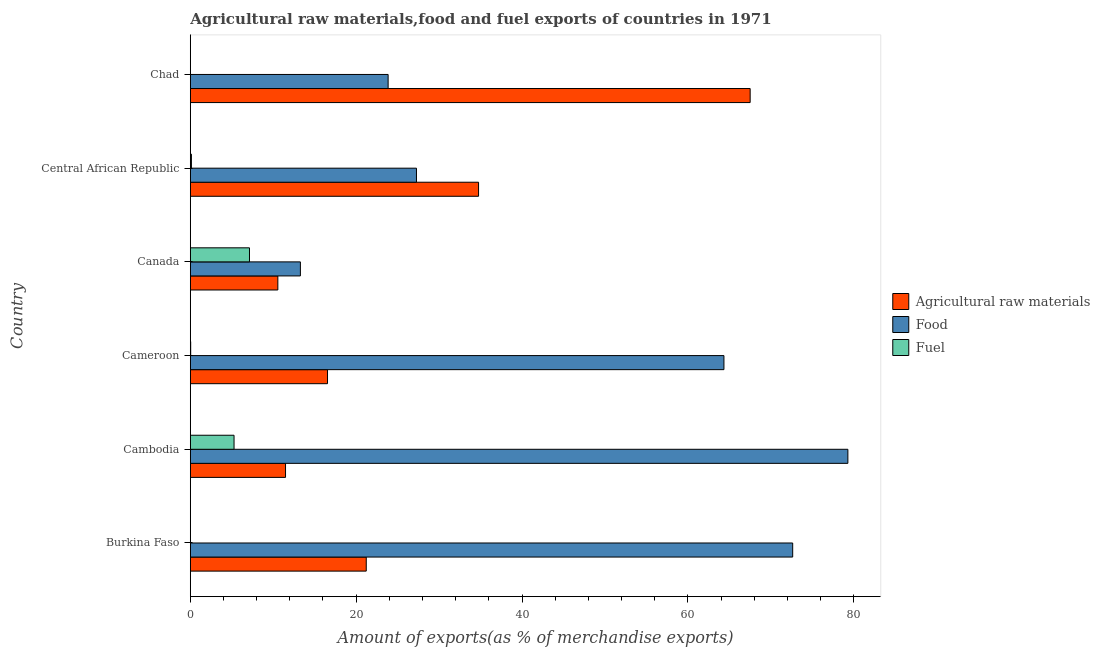How many bars are there on the 3rd tick from the top?
Offer a terse response. 3. How many bars are there on the 5th tick from the bottom?
Offer a very short reply. 3. What is the label of the 4th group of bars from the top?
Keep it short and to the point. Cameroon. What is the percentage of food exports in Chad?
Keep it short and to the point. 23.85. Across all countries, what is the maximum percentage of raw materials exports?
Your response must be concise. 67.51. Across all countries, what is the minimum percentage of fuel exports?
Your answer should be very brief. 0.01. In which country was the percentage of food exports maximum?
Give a very brief answer. Cambodia. In which country was the percentage of food exports minimum?
Keep it short and to the point. Canada. What is the total percentage of food exports in the graph?
Your answer should be very brief. 280.68. What is the difference between the percentage of fuel exports in Cameroon and that in Canada?
Ensure brevity in your answer.  -7.09. What is the difference between the percentage of fuel exports in Cambodia and the percentage of food exports in Burkina Faso?
Ensure brevity in your answer.  -67.36. What is the average percentage of food exports per country?
Make the answer very short. 46.78. What is the difference between the percentage of raw materials exports and percentage of food exports in Canada?
Your answer should be compact. -2.72. In how many countries, is the percentage of food exports greater than 72 %?
Provide a succinct answer. 2. What is the ratio of the percentage of food exports in Canada to that in Central African Republic?
Provide a short and direct response. 0.49. Is the difference between the percentage of raw materials exports in Burkina Faso and Cameroon greater than the difference between the percentage of food exports in Burkina Faso and Cameroon?
Offer a very short reply. No. What is the difference between the highest and the second highest percentage of raw materials exports?
Provide a succinct answer. 32.75. What is the difference between the highest and the lowest percentage of food exports?
Give a very brief answer. 66.02. In how many countries, is the percentage of fuel exports greater than the average percentage of fuel exports taken over all countries?
Provide a short and direct response. 2. What does the 2nd bar from the top in Central African Republic represents?
Provide a succinct answer. Food. What does the 1st bar from the bottom in Cameroon represents?
Offer a terse response. Agricultural raw materials. Is it the case that in every country, the sum of the percentage of raw materials exports and percentage of food exports is greater than the percentage of fuel exports?
Your answer should be compact. Yes. How many countries are there in the graph?
Your answer should be very brief. 6. Does the graph contain grids?
Keep it short and to the point. No. What is the title of the graph?
Make the answer very short. Agricultural raw materials,food and fuel exports of countries in 1971. What is the label or title of the X-axis?
Your answer should be very brief. Amount of exports(as % of merchandise exports). What is the Amount of exports(as % of merchandise exports) of Agricultural raw materials in Burkina Faso?
Keep it short and to the point. 21.22. What is the Amount of exports(as % of merchandise exports) of Food in Burkina Faso?
Provide a short and direct response. 72.64. What is the Amount of exports(as % of merchandise exports) of Fuel in Burkina Faso?
Your answer should be very brief. 0.02. What is the Amount of exports(as % of merchandise exports) in Agricultural raw materials in Cambodia?
Ensure brevity in your answer.  11.48. What is the Amount of exports(as % of merchandise exports) in Food in Cambodia?
Your answer should be compact. 79.29. What is the Amount of exports(as % of merchandise exports) in Fuel in Cambodia?
Offer a terse response. 5.28. What is the Amount of exports(as % of merchandise exports) in Agricultural raw materials in Cameroon?
Your answer should be very brief. 16.55. What is the Amount of exports(as % of merchandise exports) in Food in Cameroon?
Offer a terse response. 64.35. What is the Amount of exports(as % of merchandise exports) of Fuel in Cameroon?
Your response must be concise. 0.05. What is the Amount of exports(as % of merchandise exports) of Agricultural raw materials in Canada?
Give a very brief answer. 10.56. What is the Amount of exports(as % of merchandise exports) of Food in Canada?
Make the answer very short. 13.28. What is the Amount of exports(as % of merchandise exports) of Fuel in Canada?
Your answer should be very brief. 7.14. What is the Amount of exports(as % of merchandise exports) of Agricultural raw materials in Central African Republic?
Ensure brevity in your answer.  34.76. What is the Amount of exports(as % of merchandise exports) in Food in Central African Republic?
Your answer should be very brief. 27.27. What is the Amount of exports(as % of merchandise exports) of Fuel in Central African Republic?
Your answer should be compact. 0.14. What is the Amount of exports(as % of merchandise exports) of Agricultural raw materials in Chad?
Give a very brief answer. 67.51. What is the Amount of exports(as % of merchandise exports) in Food in Chad?
Provide a succinct answer. 23.85. What is the Amount of exports(as % of merchandise exports) in Fuel in Chad?
Offer a very short reply. 0.01. Across all countries, what is the maximum Amount of exports(as % of merchandise exports) in Agricultural raw materials?
Make the answer very short. 67.51. Across all countries, what is the maximum Amount of exports(as % of merchandise exports) of Food?
Offer a terse response. 79.29. Across all countries, what is the maximum Amount of exports(as % of merchandise exports) of Fuel?
Provide a short and direct response. 7.14. Across all countries, what is the minimum Amount of exports(as % of merchandise exports) of Agricultural raw materials?
Ensure brevity in your answer.  10.56. Across all countries, what is the minimum Amount of exports(as % of merchandise exports) of Food?
Your response must be concise. 13.28. Across all countries, what is the minimum Amount of exports(as % of merchandise exports) in Fuel?
Your response must be concise. 0.01. What is the total Amount of exports(as % of merchandise exports) in Agricultural raw materials in the graph?
Make the answer very short. 162.08. What is the total Amount of exports(as % of merchandise exports) of Food in the graph?
Make the answer very short. 280.68. What is the total Amount of exports(as % of merchandise exports) of Fuel in the graph?
Make the answer very short. 12.63. What is the difference between the Amount of exports(as % of merchandise exports) in Agricultural raw materials in Burkina Faso and that in Cambodia?
Your answer should be very brief. 9.73. What is the difference between the Amount of exports(as % of merchandise exports) of Food in Burkina Faso and that in Cambodia?
Your answer should be very brief. -6.65. What is the difference between the Amount of exports(as % of merchandise exports) of Fuel in Burkina Faso and that in Cambodia?
Your answer should be compact. -5.25. What is the difference between the Amount of exports(as % of merchandise exports) in Agricultural raw materials in Burkina Faso and that in Cameroon?
Your answer should be very brief. 4.67. What is the difference between the Amount of exports(as % of merchandise exports) in Food in Burkina Faso and that in Cameroon?
Give a very brief answer. 8.29. What is the difference between the Amount of exports(as % of merchandise exports) in Fuel in Burkina Faso and that in Cameroon?
Your answer should be compact. -0.02. What is the difference between the Amount of exports(as % of merchandise exports) of Agricultural raw materials in Burkina Faso and that in Canada?
Make the answer very short. 10.66. What is the difference between the Amount of exports(as % of merchandise exports) of Food in Burkina Faso and that in Canada?
Your answer should be compact. 59.36. What is the difference between the Amount of exports(as % of merchandise exports) of Fuel in Burkina Faso and that in Canada?
Your answer should be very brief. -7.11. What is the difference between the Amount of exports(as % of merchandise exports) of Agricultural raw materials in Burkina Faso and that in Central African Republic?
Your answer should be very brief. -13.54. What is the difference between the Amount of exports(as % of merchandise exports) in Food in Burkina Faso and that in Central African Republic?
Keep it short and to the point. 45.37. What is the difference between the Amount of exports(as % of merchandise exports) in Fuel in Burkina Faso and that in Central African Republic?
Your response must be concise. -0.11. What is the difference between the Amount of exports(as % of merchandise exports) of Agricultural raw materials in Burkina Faso and that in Chad?
Your answer should be very brief. -46.29. What is the difference between the Amount of exports(as % of merchandise exports) of Food in Burkina Faso and that in Chad?
Offer a very short reply. 48.78. What is the difference between the Amount of exports(as % of merchandise exports) of Fuel in Burkina Faso and that in Chad?
Provide a succinct answer. 0.01. What is the difference between the Amount of exports(as % of merchandise exports) in Agricultural raw materials in Cambodia and that in Cameroon?
Your answer should be compact. -5.06. What is the difference between the Amount of exports(as % of merchandise exports) of Food in Cambodia and that in Cameroon?
Make the answer very short. 14.95. What is the difference between the Amount of exports(as % of merchandise exports) in Fuel in Cambodia and that in Cameroon?
Your response must be concise. 5.23. What is the difference between the Amount of exports(as % of merchandise exports) in Agricultural raw materials in Cambodia and that in Canada?
Offer a terse response. 0.93. What is the difference between the Amount of exports(as % of merchandise exports) in Food in Cambodia and that in Canada?
Give a very brief answer. 66.02. What is the difference between the Amount of exports(as % of merchandise exports) in Fuel in Cambodia and that in Canada?
Offer a terse response. -1.86. What is the difference between the Amount of exports(as % of merchandise exports) in Agricultural raw materials in Cambodia and that in Central African Republic?
Provide a short and direct response. -23.28. What is the difference between the Amount of exports(as % of merchandise exports) of Food in Cambodia and that in Central African Republic?
Your answer should be very brief. 52.02. What is the difference between the Amount of exports(as % of merchandise exports) in Fuel in Cambodia and that in Central African Republic?
Offer a terse response. 5.14. What is the difference between the Amount of exports(as % of merchandise exports) of Agricultural raw materials in Cambodia and that in Chad?
Provide a short and direct response. -56.03. What is the difference between the Amount of exports(as % of merchandise exports) in Food in Cambodia and that in Chad?
Ensure brevity in your answer.  55.44. What is the difference between the Amount of exports(as % of merchandise exports) in Fuel in Cambodia and that in Chad?
Provide a short and direct response. 5.27. What is the difference between the Amount of exports(as % of merchandise exports) of Agricultural raw materials in Cameroon and that in Canada?
Give a very brief answer. 5.99. What is the difference between the Amount of exports(as % of merchandise exports) of Food in Cameroon and that in Canada?
Keep it short and to the point. 51.07. What is the difference between the Amount of exports(as % of merchandise exports) in Fuel in Cameroon and that in Canada?
Provide a succinct answer. -7.09. What is the difference between the Amount of exports(as % of merchandise exports) in Agricultural raw materials in Cameroon and that in Central African Republic?
Make the answer very short. -18.21. What is the difference between the Amount of exports(as % of merchandise exports) in Food in Cameroon and that in Central African Republic?
Your response must be concise. 37.07. What is the difference between the Amount of exports(as % of merchandise exports) in Fuel in Cameroon and that in Central African Republic?
Keep it short and to the point. -0.09. What is the difference between the Amount of exports(as % of merchandise exports) in Agricultural raw materials in Cameroon and that in Chad?
Ensure brevity in your answer.  -50.96. What is the difference between the Amount of exports(as % of merchandise exports) of Food in Cameroon and that in Chad?
Ensure brevity in your answer.  40.49. What is the difference between the Amount of exports(as % of merchandise exports) of Fuel in Cameroon and that in Chad?
Offer a terse response. 0.04. What is the difference between the Amount of exports(as % of merchandise exports) of Agricultural raw materials in Canada and that in Central African Republic?
Your response must be concise. -24.2. What is the difference between the Amount of exports(as % of merchandise exports) of Food in Canada and that in Central African Republic?
Ensure brevity in your answer.  -14. What is the difference between the Amount of exports(as % of merchandise exports) in Fuel in Canada and that in Central African Republic?
Your response must be concise. 7. What is the difference between the Amount of exports(as % of merchandise exports) of Agricultural raw materials in Canada and that in Chad?
Provide a short and direct response. -56.95. What is the difference between the Amount of exports(as % of merchandise exports) of Food in Canada and that in Chad?
Provide a short and direct response. -10.58. What is the difference between the Amount of exports(as % of merchandise exports) of Fuel in Canada and that in Chad?
Your answer should be compact. 7.13. What is the difference between the Amount of exports(as % of merchandise exports) of Agricultural raw materials in Central African Republic and that in Chad?
Give a very brief answer. -32.75. What is the difference between the Amount of exports(as % of merchandise exports) in Food in Central African Republic and that in Chad?
Provide a short and direct response. 3.42. What is the difference between the Amount of exports(as % of merchandise exports) in Fuel in Central African Republic and that in Chad?
Your answer should be very brief. 0.13. What is the difference between the Amount of exports(as % of merchandise exports) of Agricultural raw materials in Burkina Faso and the Amount of exports(as % of merchandise exports) of Food in Cambodia?
Your answer should be compact. -58.07. What is the difference between the Amount of exports(as % of merchandise exports) of Agricultural raw materials in Burkina Faso and the Amount of exports(as % of merchandise exports) of Fuel in Cambodia?
Your response must be concise. 15.94. What is the difference between the Amount of exports(as % of merchandise exports) of Food in Burkina Faso and the Amount of exports(as % of merchandise exports) of Fuel in Cambodia?
Make the answer very short. 67.36. What is the difference between the Amount of exports(as % of merchandise exports) of Agricultural raw materials in Burkina Faso and the Amount of exports(as % of merchandise exports) of Food in Cameroon?
Your answer should be compact. -43.13. What is the difference between the Amount of exports(as % of merchandise exports) in Agricultural raw materials in Burkina Faso and the Amount of exports(as % of merchandise exports) in Fuel in Cameroon?
Make the answer very short. 21.17. What is the difference between the Amount of exports(as % of merchandise exports) in Food in Burkina Faso and the Amount of exports(as % of merchandise exports) in Fuel in Cameroon?
Make the answer very short. 72.59. What is the difference between the Amount of exports(as % of merchandise exports) in Agricultural raw materials in Burkina Faso and the Amount of exports(as % of merchandise exports) in Food in Canada?
Your answer should be compact. 7.94. What is the difference between the Amount of exports(as % of merchandise exports) in Agricultural raw materials in Burkina Faso and the Amount of exports(as % of merchandise exports) in Fuel in Canada?
Your response must be concise. 14.08. What is the difference between the Amount of exports(as % of merchandise exports) of Food in Burkina Faso and the Amount of exports(as % of merchandise exports) of Fuel in Canada?
Provide a succinct answer. 65.5. What is the difference between the Amount of exports(as % of merchandise exports) of Agricultural raw materials in Burkina Faso and the Amount of exports(as % of merchandise exports) of Food in Central African Republic?
Your answer should be very brief. -6.05. What is the difference between the Amount of exports(as % of merchandise exports) in Agricultural raw materials in Burkina Faso and the Amount of exports(as % of merchandise exports) in Fuel in Central African Republic?
Your answer should be very brief. 21.08. What is the difference between the Amount of exports(as % of merchandise exports) of Food in Burkina Faso and the Amount of exports(as % of merchandise exports) of Fuel in Central African Republic?
Your response must be concise. 72.5. What is the difference between the Amount of exports(as % of merchandise exports) in Agricultural raw materials in Burkina Faso and the Amount of exports(as % of merchandise exports) in Food in Chad?
Keep it short and to the point. -2.64. What is the difference between the Amount of exports(as % of merchandise exports) in Agricultural raw materials in Burkina Faso and the Amount of exports(as % of merchandise exports) in Fuel in Chad?
Ensure brevity in your answer.  21.21. What is the difference between the Amount of exports(as % of merchandise exports) of Food in Burkina Faso and the Amount of exports(as % of merchandise exports) of Fuel in Chad?
Your answer should be compact. 72.63. What is the difference between the Amount of exports(as % of merchandise exports) of Agricultural raw materials in Cambodia and the Amount of exports(as % of merchandise exports) of Food in Cameroon?
Your response must be concise. -52.86. What is the difference between the Amount of exports(as % of merchandise exports) of Agricultural raw materials in Cambodia and the Amount of exports(as % of merchandise exports) of Fuel in Cameroon?
Provide a short and direct response. 11.44. What is the difference between the Amount of exports(as % of merchandise exports) of Food in Cambodia and the Amount of exports(as % of merchandise exports) of Fuel in Cameroon?
Offer a very short reply. 79.25. What is the difference between the Amount of exports(as % of merchandise exports) in Agricultural raw materials in Cambodia and the Amount of exports(as % of merchandise exports) in Food in Canada?
Offer a terse response. -1.79. What is the difference between the Amount of exports(as % of merchandise exports) in Agricultural raw materials in Cambodia and the Amount of exports(as % of merchandise exports) in Fuel in Canada?
Give a very brief answer. 4.35. What is the difference between the Amount of exports(as % of merchandise exports) of Food in Cambodia and the Amount of exports(as % of merchandise exports) of Fuel in Canada?
Keep it short and to the point. 72.15. What is the difference between the Amount of exports(as % of merchandise exports) in Agricultural raw materials in Cambodia and the Amount of exports(as % of merchandise exports) in Food in Central African Republic?
Your response must be concise. -15.79. What is the difference between the Amount of exports(as % of merchandise exports) in Agricultural raw materials in Cambodia and the Amount of exports(as % of merchandise exports) in Fuel in Central African Republic?
Offer a very short reply. 11.35. What is the difference between the Amount of exports(as % of merchandise exports) of Food in Cambodia and the Amount of exports(as % of merchandise exports) of Fuel in Central African Republic?
Keep it short and to the point. 79.16. What is the difference between the Amount of exports(as % of merchandise exports) in Agricultural raw materials in Cambodia and the Amount of exports(as % of merchandise exports) in Food in Chad?
Your answer should be very brief. -12.37. What is the difference between the Amount of exports(as % of merchandise exports) in Agricultural raw materials in Cambodia and the Amount of exports(as % of merchandise exports) in Fuel in Chad?
Your answer should be compact. 11.47. What is the difference between the Amount of exports(as % of merchandise exports) of Food in Cambodia and the Amount of exports(as % of merchandise exports) of Fuel in Chad?
Provide a succinct answer. 79.28. What is the difference between the Amount of exports(as % of merchandise exports) of Agricultural raw materials in Cameroon and the Amount of exports(as % of merchandise exports) of Food in Canada?
Keep it short and to the point. 3.27. What is the difference between the Amount of exports(as % of merchandise exports) in Agricultural raw materials in Cameroon and the Amount of exports(as % of merchandise exports) in Fuel in Canada?
Provide a short and direct response. 9.41. What is the difference between the Amount of exports(as % of merchandise exports) in Food in Cameroon and the Amount of exports(as % of merchandise exports) in Fuel in Canada?
Offer a very short reply. 57.21. What is the difference between the Amount of exports(as % of merchandise exports) of Agricultural raw materials in Cameroon and the Amount of exports(as % of merchandise exports) of Food in Central African Republic?
Provide a succinct answer. -10.73. What is the difference between the Amount of exports(as % of merchandise exports) of Agricultural raw materials in Cameroon and the Amount of exports(as % of merchandise exports) of Fuel in Central African Republic?
Your response must be concise. 16.41. What is the difference between the Amount of exports(as % of merchandise exports) in Food in Cameroon and the Amount of exports(as % of merchandise exports) in Fuel in Central African Republic?
Offer a very short reply. 64.21. What is the difference between the Amount of exports(as % of merchandise exports) of Agricultural raw materials in Cameroon and the Amount of exports(as % of merchandise exports) of Food in Chad?
Your answer should be very brief. -7.31. What is the difference between the Amount of exports(as % of merchandise exports) of Agricultural raw materials in Cameroon and the Amount of exports(as % of merchandise exports) of Fuel in Chad?
Give a very brief answer. 16.54. What is the difference between the Amount of exports(as % of merchandise exports) in Food in Cameroon and the Amount of exports(as % of merchandise exports) in Fuel in Chad?
Your answer should be very brief. 64.34. What is the difference between the Amount of exports(as % of merchandise exports) of Agricultural raw materials in Canada and the Amount of exports(as % of merchandise exports) of Food in Central African Republic?
Ensure brevity in your answer.  -16.72. What is the difference between the Amount of exports(as % of merchandise exports) in Agricultural raw materials in Canada and the Amount of exports(as % of merchandise exports) in Fuel in Central African Republic?
Keep it short and to the point. 10.42. What is the difference between the Amount of exports(as % of merchandise exports) of Food in Canada and the Amount of exports(as % of merchandise exports) of Fuel in Central African Republic?
Keep it short and to the point. 13.14. What is the difference between the Amount of exports(as % of merchandise exports) of Agricultural raw materials in Canada and the Amount of exports(as % of merchandise exports) of Food in Chad?
Keep it short and to the point. -13.3. What is the difference between the Amount of exports(as % of merchandise exports) of Agricultural raw materials in Canada and the Amount of exports(as % of merchandise exports) of Fuel in Chad?
Your response must be concise. 10.55. What is the difference between the Amount of exports(as % of merchandise exports) of Food in Canada and the Amount of exports(as % of merchandise exports) of Fuel in Chad?
Provide a succinct answer. 13.27. What is the difference between the Amount of exports(as % of merchandise exports) of Agricultural raw materials in Central African Republic and the Amount of exports(as % of merchandise exports) of Food in Chad?
Ensure brevity in your answer.  10.91. What is the difference between the Amount of exports(as % of merchandise exports) in Agricultural raw materials in Central African Republic and the Amount of exports(as % of merchandise exports) in Fuel in Chad?
Keep it short and to the point. 34.75. What is the difference between the Amount of exports(as % of merchandise exports) of Food in Central African Republic and the Amount of exports(as % of merchandise exports) of Fuel in Chad?
Offer a terse response. 27.26. What is the average Amount of exports(as % of merchandise exports) of Agricultural raw materials per country?
Offer a terse response. 27.01. What is the average Amount of exports(as % of merchandise exports) in Food per country?
Provide a short and direct response. 46.78. What is the average Amount of exports(as % of merchandise exports) of Fuel per country?
Provide a short and direct response. 2.1. What is the difference between the Amount of exports(as % of merchandise exports) in Agricultural raw materials and Amount of exports(as % of merchandise exports) in Food in Burkina Faso?
Give a very brief answer. -51.42. What is the difference between the Amount of exports(as % of merchandise exports) in Agricultural raw materials and Amount of exports(as % of merchandise exports) in Fuel in Burkina Faso?
Your answer should be compact. 21.19. What is the difference between the Amount of exports(as % of merchandise exports) in Food and Amount of exports(as % of merchandise exports) in Fuel in Burkina Faso?
Keep it short and to the point. 72.61. What is the difference between the Amount of exports(as % of merchandise exports) in Agricultural raw materials and Amount of exports(as % of merchandise exports) in Food in Cambodia?
Offer a terse response. -67.81. What is the difference between the Amount of exports(as % of merchandise exports) in Agricultural raw materials and Amount of exports(as % of merchandise exports) in Fuel in Cambodia?
Provide a short and direct response. 6.21. What is the difference between the Amount of exports(as % of merchandise exports) in Food and Amount of exports(as % of merchandise exports) in Fuel in Cambodia?
Give a very brief answer. 74.02. What is the difference between the Amount of exports(as % of merchandise exports) of Agricultural raw materials and Amount of exports(as % of merchandise exports) of Food in Cameroon?
Make the answer very short. -47.8. What is the difference between the Amount of exports(as % of merchandise exports) in Agricultural raw materials and Amount of exports(as % of merchandise exports) in Fuel in Cameroon?
Provide a succinct answer. 16.5. What is the difference between the Amount of exports(as % of merchandise exports) of Food and Amount of exports(as % of merchandise exports) of Fuel in Cameroon?
Provide a succinct answer. 64.3. What is the difference between the Amount of exports(as % of merchandise exports) of Agricultural raw materials and Amount of exports(as % of merchandise exports) of Food in Canada?
Offer a very short reply. -2.72. What is the difference between the Amount of exports(as % of merchandise exports) of Agricultural raw materials and Amount of exports(as % of merchandise exports) of Fuel in Canada?
Your response must be concise. 3.42. What is the difference between the Amount of exports(as % of merchandise exports) in Food and Amount of exports(as % of merchandise exports) in Fuel in Canada?
Offer a terse response. 6.14. What is the difference between the Amount of exports(as % of merchandise exports) of Agricultural raw materials and Amount of exports(as % of merchandise exports) of Food in Central African Republic?
Ensure brevity in your answer.  7.49. What is the difference between the Amount of exports(as % of merchandise exports) in Agricultural raw materials and Amount of exports(as % of merchandise exports) in Fuel in Central African Republic?
Your answer should be very brief. 34.63. What is the difference between the Amount of exports(as % of merchandise exports) of Food and Amount of exports(as % of merchandise exports) of Fuel in Central African Republic?
Offer a very short reply. 27.14. What is the difference between the Amount of exports(as % of merchandise exports) in Agricultural raw materials and Amount of exports(as % of merchandise exports) in Food in Chad?
Ensure brevity in your answer.  43.66. What is the difference between the Amount of exports(as % of merchandise exports) of Agricultural raw materials and Amount of exports(as % of merchandise exports) of Fuel in Chad?
Make the answer very short. 67.5. What is the difference between the Amount of exports(as % of merchandise exports) of Food and Amount of exports(as % of merchandise exports) of Fuel in Chad?
Provide a succinct answer. 23.84. What is the ratio of the Amount of exports(as % of merchandise exports) of Agricultural raw materials in Burkina Faso to that in Cambodia?
Keep it short and to the point. 1.85. What is the ratio of the Amount of exports(as % of merchandise exports) in Food in Burkina Faso to that in Cambodia?
Your response must be concise. 0.92. What is the ratio of the Amount of exports(as % of merchandise exports) in Fuel in Burkina Faso to that in Cambodia?
Offer a very short reply. 0. What is the ratio of the Amount of exports(as % of merchandise exports) in Agricultural raw materials in Burkina Faso to that in Cameroon?
Keep it short and to the point. 1.28. What is the ratio of the Amount of exports(as % of merchandise exports) of Food in Burkina Faso to that in Cameroon?
Offer a very short reply. 1.13. What is the ratio of the Amount of exports(as % of merchandise exports) of Fuel in Burkina Faso to that in Cameroon?
Your answer should be very brief. 0.49. What is the ratio of the Amount of exports(as % of merchandise exports) in Agricultural raw materials in Burkina Faso to that in Canada?
Offer a very short reply. 2.01. What is the ratio of the Amount of exports(as % of merchandise exports) of Food in Burkina Faso to that in Canada?
Offer a very short reply. 5.47. What is the ratio of the Amount of exports(as % of merchandise exports) of Fuel in Burkina Faso to that in Canada?
Ensure brevity in your answer.  0. What is the ratio of the Amount of exports(as % of merchandise exports) in Agricultural raw materials in Burkina Faso to that in Central African Republic?
Give a very brief answer. 0.61. What is the ratio of the Amount of exports(as % of merchandise exports) of Food in Burkina Faso to that in Central African Republic?
Provide a short and direct response. 2.66. What is the ratio of the Amount of exports(as % of merchandise exports) in Fuel in Burkina Faso to that in Central African Republic?
Ensure brevity in your answer.  0.17. What is the ratio of the Amount of exports(as % of merchandise exports) in Agricultural raw materials in Burkina Faso to that in Chad?
Offer a terse response. 0.31. What is the ratio of the Amount of exports(as % of merchandise exports) in Food in Burkina Faso to that in Chad?
Offer a terse response. 3.05. What is the ratio of the Amount of exports(as % of merchandise exports) of Fuel in Burkina Faso to that in Chad?
Your response must be concise. 2.42. What is the ratio of the Amount of exports(as % of merchandise exports) of Agricultural raw materials in Cambodia to that in Cameroon?
Provide a succinct answer. 0.69. What is the ratio of the Amount of exports(as % of merchandise exports) of Food in Cambodia to that in Cameroon?
Keep it short and to the point. 1.23. What is the ratio of the Amount of exports(as % of merchandise exports) of Fuel in Cambodia to that in Cameroon?
Provide a succinct answer. 111.1. What is the ratio of the Amount of exports(as % of merchandise exports) of Agricultural raw materials in Cambodia to that in Canada?
Your answer should be very brief. 1.09. What is the ratio of the Amount of exports(as % of merchandise exports) of Food in Cambodia to that in Canada?
Ensure brevity in your answer.  5.97. What is the ratio of the Amount of exports(as % of merchandise exports) of Fuel in Cambodia to that in Canada?
Offer a very short reply. 0.74. What is the ratio of the Amount of exports(as % of merchandise exports) of Agricultural raw materials in Cambodia to that in Central African Republic?
Offer a very short reply. 0.33. What is the ratio of the Amount of exports(as % of merchandise exports) in Food in Cambodia to that in Central African Republic?
Make the answer very short. 2.91. What is the ratio of the Amount of exports(as % of merchandise exports) of Fuel in Cambodia to that in Central African Republic?
Give a very brief answer. 38.97. What is the ratio of the Amount of exports(as % of merchandise exports) of Agricultural raw materials in Cambodia to that in Chad?
Your answer should be compact. 0.17. What is the ratio of the Amount of exports(as % of merchandise exports) of Food in Cambodia to that in Chad?
Offer a terse response. 3.32. What is the ratio of the Amount of exports(as % of merchandise exports) of Fuel in Cambodia to that in Chad?
Make the answer very short. 546.51. What is the ratio of the Amount of exports(as % of merchandise exports) of Agricultural raw materials in Cameroon to that in Canada?
Your answer should be very brief. 1.57. What is the ratio of the Amount of exports(as % of merchandise exports) in Food in Cameroon to that in Canada?
Keep it short and to the point. 4.85. What is the ratio of the Amount of exports(as % of merchandise exports) in Fuel in Cameroon to that in Canada?
Your answer should be compact. 0.01. What is the ratio of the Amount of exports(as % of merchandise exports) of Agricultural raw materials in Cameroon to that in Central African Republic?
Your answer should be compact. 0.48. What is the ratio of the Amount of exports(as % of merchandise exports) in Food in Cameroon to that in Central African Republic?
Your response must be concise. 2.36. What is the ratio of the Amount of exports(as % of merchandise exports) of Fuel in Cameroon to that in Central African Republic?
Your response must be concise. 0.35. What is the ratio of the Amount of exports(as % of merchandise exports) of Agricultural raw materials in Cameroon to that in Chad?
Your answer should be very brief. 0.25. What is the ratio of the Amount of exports(as % of merchandise exports) of Food in Cameroon to that in Chad?
Your answer should be compact. 2.7. What is the ratio of the Amount of exports(as % of merchandise exports) of Fuel in Cameroon to that in Chad?
Provide a short and direct response. 4.92. What is the ratio of the Amount of exports(as % of merchandise exports) in Agricultural raw materials in Canada to that in Central African Republic?
Offer a terse response. 0.3. What is the ratio of the Amount of exports(as % of merchandise exports) of Food in Canada to that in Central African Republic?
Offer a very short reply. 0.49. What is the ratio of the Amount of exports(as % of merchandise exports) in Fuel in Canada to that in Central African Republic?
Give a very brief answer. 52.73. What is the ratio of the Amount of exports(as % of merchandise exports) in Agricultural raw materials in Canada to that in Chad?
Your answer should be very brief. 0.16. What is the ratio of the Amount of exports(as % of merchandise exports) in Food in Canada to that in Chad?
Offer a very short reply. 0.56. What is the ratio of the Amount of exports(as % of merchandise exports) in Fuel in Canada to that in Chad?
Offer a very short reply. 739.51. What is the ratio of the Amount of exports(as % of merchandise exports) of Agricultural raw materials in Central African Republic to that in Chad?
Provide a short and direct response. 0.51. What is the ratio of the Amount of exports(as % of merchandise exports) of Food in Central African Republic to that in Chad?
Give a very brief answer. 1.14. What is the ratio of the Amount of exports(as % of merchandise exports) in Fuel in Central African Republic to that in Chad?
Provide a short and direct response. 14.03. What is the difference between the highest and the second highest Amount of exports(as % of merchandise exports) in Agricultural raw materials?
Ensure brevity in your answer.  32.75. What is the difference between the highest and the second highest Amount of exports(as % of merchandise exports) of Food?
Provide a succinct answer. 6.65. What is the difference between the highest and the second highest Amount of exports(as % of merchandise exports) in Fuel?
Make the answer very short. 1.86. What is the difference between the highest and the lowest Amount of exports(as % of merchandise exports) of Agricultural raw materials?
Ensure brevity in your answer.  56.95. What is the difference between the highest and the lowest Amount of exports(as % of merchandise exports) of Food?
Give a very brief answer. 66.02. What is the difference between the highest and the lowest Amount of exports(as % of merchandise exports) in Fuel?
Provide a succinct answer. 7.13. 